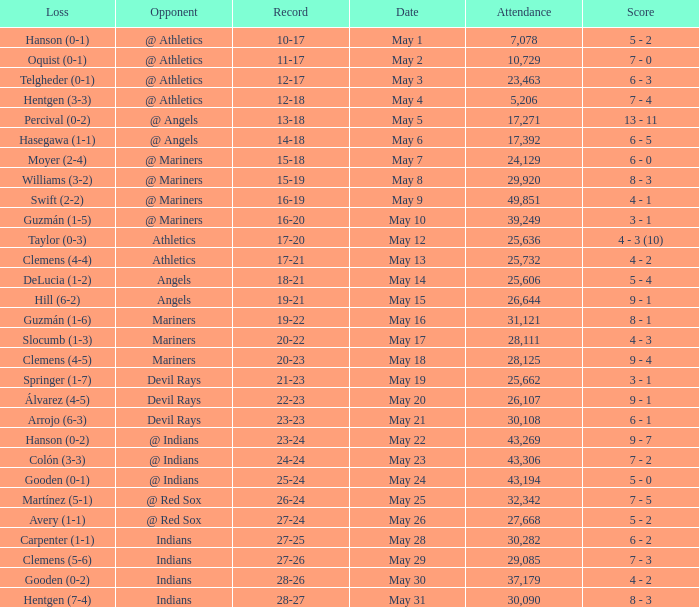Who lost on May 31? Hentgen (7-4). 